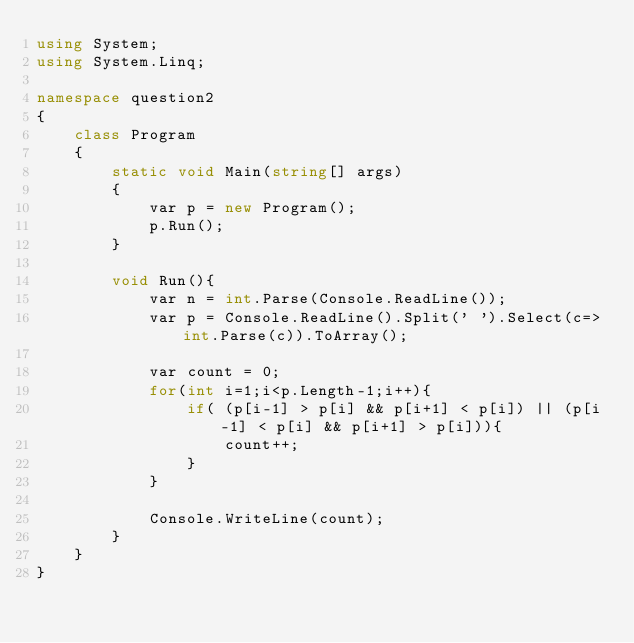Convert code to text. <code><loc_0><loc_0><loc_500><loc_500><_C#_>using System;
using System.Linq;

namespace question2
{
    class Program
    {
        static void Main(string[] args)
        {
            var p = new Program();
            p.Run();
        }

        void Run(){
            var n = int.Parse(Console.ReadLine());
            var p = Console.ReadLine().Split(' ').Select(c=>int.Parse(c)).ToArray();

            var count = 0;
            for(int i=1;i<p.Length-1;i++){
                if( (p[i-1] > p[i] && p[i+1] < p[i]) || (p[i-1] < p[i] && p[i+1] > p[i])){
                    count++;
                }
            }

            Console.WriteLine(count);
        }
    }
}
</code> 